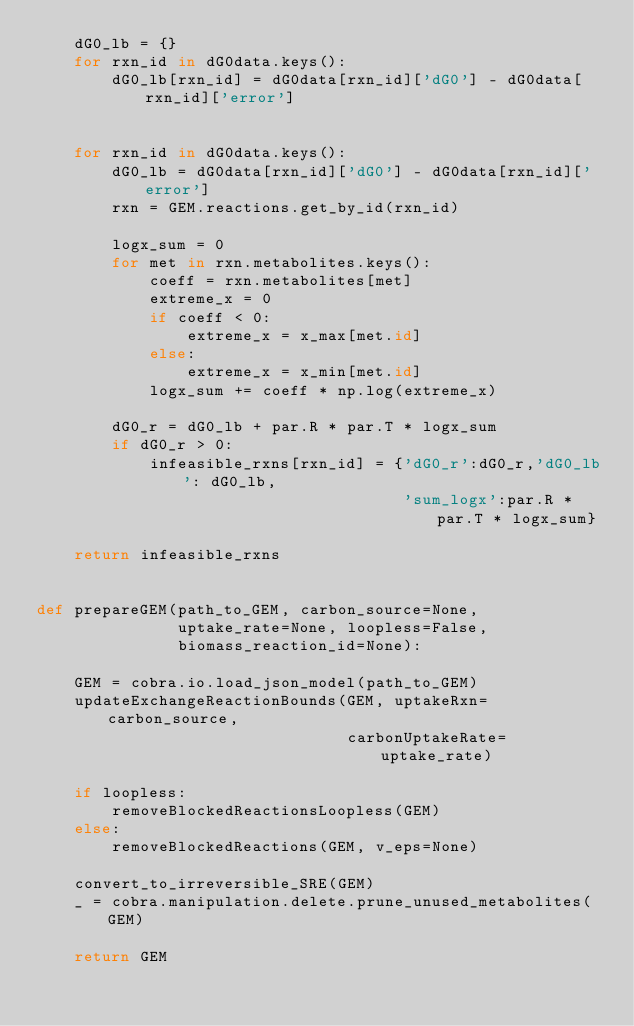<code> <loc_0><loc_0><loc_500><loc_500><_Python_>    dG0_lb = {}
    for rxn_id in dG0data.keys():
        dG0_lb[rxn_id] = dG0data[rxn_id]['dG0'] - dG0data[rxn_id]['error']
        
        
    for rxn_id in dG0data.keys():
        dG0_lb = dG0data[rxn_id]['dG0'] - dG0data[rxn_id]['error']
        rxn = GEM.reactions.get_by_id(rxn_id)
        
        logx_sum = 0
        for met in rxn.metabolites.keys():
            coeff = rxn.metabolites[met]
            extreme_x = 0
            if coeff < 0:
                extreme_x = x_max[met.id]
            else:
                extreme_x = x_min[met.id]
            logx_sum += coeff * np.log(extreme_x)
        
        dG0_r = dG0_lb + par.R * par.T * logx_sum
        if dG0_r > 0:
            infeasible_rxns[rxn_id] = {'dG0_r':dG0_r,'dG0_lb': dG0_lb,
                                       'sum_logx':par.R * par.T * logx_sum}
            
    return infeasible_rxns
        

def prepareGEM(path_to_GEM, carbon_source=None,
               uptake_rate=None, loopless=False,
               biomass_reaction_id=None):

    GEM = cobra.io.load_json_model(path_to_GEM)
    updateExchangeReactionBounds(GEM, uptakeRxn=carbon_source,
                                 carbonUptakeRate=uptake_rate)
    
    if loopless:
        removeBlockedReactionsLoopless(GEM)
    else:
        removeBlockedReactions(GEM, v_eps=None)
    
    convert_to_irreversible_SRE(GEM)
    _ = cobra.manipulation.delete.prune_unused_metabolites(GEM)

    return GEM</code> 